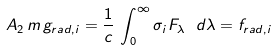Convert formula to latex. <formula><loc_0><loc_0><loc_500><loc_500>A _ { 2 } \, m \, g _ { r a d , i } = \frac { 1 } { c } \, \int _ { 0 } ^ { \infty } \sigma _ { i } F _ { \lambda } \ d \lambda = f _ { r a d , i }</formula> 